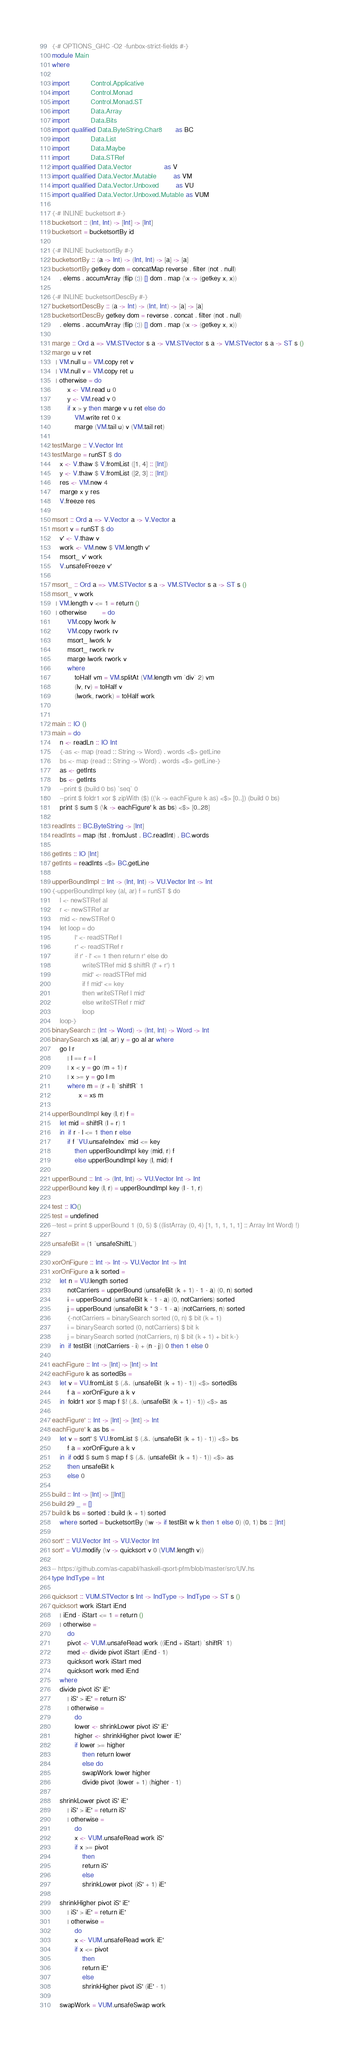<code> <loc_0><loc_0><loc_500><loc_500><_Haskell_>{-# OPTIONS_GHC -O2 -funbox-strict-fields #-}
module Main
where

import           Control.Applicative
import           Control.Monad
import           Control.Monad.ST
import           Data.Array
import           Data.Bits
import qualified Data.ByteString.Char8       as BC
import           Data.List
import           Data.Maybe
import           Data.STRef
import qualified Data.Vector                 as V
import qualified Data.Vector.Mutable         as VM
import qualified Data.Vector.Unboxed         as VU
import qualified Data.Vector.Unboxed.Mutable as VUM

{-# INLINE bucketsort #-}
bucketsort :: (Int, Int) -> [Int] -> [Int]
bucketsort = bucketsortBy id

{-# INLINE bucketsortBy #-}
bucketsortBy :: (a -> Int) -> (Int, Int) -> [a] -> [a]
bucketsortBy getkey dom = concatMap reverse . filter (not . null)
    . elems . accumArray (flip (:)) [] dom . map (\x -> (getkey x, x))

{-# INLINE bucketsortDescBy #-}
bucketsortDescBy :: (a -> Int) -> (Int, Int) -> [a] -> [a]
bucketsortDescBy getkey dom = reverse . concat . filter (not . null)
    . elems . accumArray (flip (:)) [] dom . map (\x -> (getkey x, x))

marge :: Ord a => VM.STVector s a -> VM.STVector s a -> VM.STVector s a -> ST s ()
marge u v ret
  | VM.null u = VM.copy ret v
  | VM.null v = VM.copy ret u
  | otherwise = do
        x <- VM.read u 0
        y <- VM.read v 0
        if x > y then marge v u ret else do
            VM.write ret 0 x
            marge (VM.tail u) v (VM.tail ret)

testMarge :: V.Vector Int
testMarge = runST $ do
    x <- V.thaw $ V.fromList ([1, 4] :: [Int])
    y <- V.thaw $ V.fromList ([2, 3] :: [Int])
    res <- VM.new 4
    marge x y res
    V.freeze res

msort :: Ord a => V.Vector a -> V.Vector a
msort v = runST $ do
    v' <- V.thaw v
    work <- VM.new $ VM.length v'
    msort_ v' work
    V.unsafeFreeze v'

msort_ :: Ord a => VM.STVector s a -> VM.STVector s a -> ST s ()
msort_ v work
  | VM.length v <= 1 = return ()
  | otherwise        = do
        VM.copy lwork lv
        VM.copy rwork rv
        msort_ lwork lv
        msort_ rwork rv
        marge lwork rwork v
        where
            toHalf vm = VM.splitAt (VM.length vm `div` 2) vm
            (lv, rv) = toHalf v
            (lwork, rwork) = toHalf work


main :: IO ()
main = do
    n <- readLn :: IO Int
    {-as <- map (read :: String -> Word) . words <$> getLine
    bs <- map (read :: String -> Word) . words <$> getLine-}
    as <- getInts
    bs <- getInts
    --print $ (build 0 bs) `seq` 0
    --print $ foldr1 xor $ zipWith ($) ((\k -> eachFigure k as) <$> [0..]) (build 0 bs)
    print $ sum $ (\k -> eachFigure' k as bs) <$> [0..28]

readInts :: BC.ByteString -> [Int]
readInts = map (fst . fromJust . BC.readInt) . BC.words

getInts :: IO [Int]
getInts = readInts <$> BC.getLine

upperBoundImpl :: Int -> (Int, Int) -> VU.Vector Int -> Int
{-upperBoundImpl key (al, ar) f = runST $ do
    l <- newSTRef al
    r <- newSTRef ar
    mid <- newSTRef 0
    let loop = do
            l' <- readSTRef l
            r' <- readSTRef r
            if r' - l' <= 1 then return r' else do
                writeSTRef mid $ shiftR (l' + r') 1
                mid' <- readSTRef mid
                if f mid' <= key
                then writeSTRef l mid'
                else writeSTRef r mid'
                loop
    loop-}
binarySearch :: (Int -> Word) -> (Int, Int) -> Word -> Int
binarySearch xs (al, ar) y = go al ar where
    go l r
        | l == r = l
        | x < y = go (m + 1) r
        | x >= y = go l m
        where m = (r + l) `shiftR` 1
              x = xs m

upperBoundImpl key (l, r) f =
    let mid = shiftR (l + r) 1
    in  if r - l <= 1 then r else
        if f `VU.unsafeIndex` mid <= key
            then upperBoundImpl key (mid, r) f
            else upperBoundImpl key (l, mid) f

upperBound :: Int -> (Int, Int) -> VU.Vector Int -> Int
upperBound key (l, r) = upperBoundImpl key (l - 1, r)

test :: IO()
test = undefined
--test = print $ upperBound 1 (0, 5) $ ((listArray (0, 4) [1, 1, 1, 1, 1] :: Array Int Word) !)

unsafeBit = (1 `unsafeShiftL`)

xorOnFigure :: Int -> Int -> VU.Vector Int -> Int
xorOnFigure a k sorted =
    let n = VU.length sorted
        notCarriers = upperBound (unsafeBit (k + 1) - 1 - a) (0, n) sorted
        i = upperBound (unsafeBit k - 1 - a) (0, notCarriers) sorted
        j = upperBound (unsafeBit k * 3 - 1 - a) (notCarriers, n) sorted
        {-notCarriers = binarySearch sorted (0, n) $ bit (k + 1)
        i = binarySearch sorted (0, notCarriers) $ bit k
        j = binarySearch sorted (notCarriers, n) $ bit (k + 1) + bit k-}
    in  if testBit ((notCarriers - i) + (n - j)) 0 then 1 else 0

eachFigure :: Int -> [Int] -> [Int] -> Int
eachFigure k as sortedBs =
    let v = VU.fromList $ (.&. (unsafeBit (k + 1) - 1)) <$> sortedBs
        f a = xorOnFigure a k v
    in  foldr1 xor $ map f $! (.&. (unsafeBit (k + 1) - 1)) <$> as

eachFigure' :: Int -> [Int] -> [Int] -> Int
eachFigure' k as bs =
    let v = sort' $ VU.fromList $ (.&. (unsafeBit (k + 1) - 1)) <$> bs
        f a = xorOnFigure a k v
    in  if odd $ sum $ map f $ (.&. (unsafeBit (k + 1) - 1)) <$> as
        then unsafeBit k
        else 0

build :: Int -> [Int] -> [[Int]]
build 29 _ = []
build k bs = sorted : build (k + 1) sorted
    where sorted = bucketsortBy (\w -> if testBit w k then 1 else 0) (0, 1) bs :: [Int]

sort' :: VU.Vector Int -> VU.Vector Int
sort' = VU.modify (\v -> quicksort v 0 (VUM.length v))

-- https://github.com/as-capabl/haskell-qsort-pfm/blob/master/src/UV.hs
type IndType = Int

quicksort :: VUM.STVector s Int -> IndType -> IndType -> ST s ()
quicksort work iStart iEnd
    | iEnd - iStart <= 1 = return ()
    | otherwise =
        do
        pivot <- VUM.unsafeRead work ((iEnd + iStart) `shiftR` 1)
        med <- divide pivot iStart (iEnd - 1)
        quicksort work iStart med
        quicksort work med iEnd
    where
    divide pivot iS' iE'
        | iS' > iE' = return iS'
        | otherwise =
            do
            lower <- shrinkLower pivot iS' iE'
            higher <- shrinkHigher pivot lower iE'
            if lower >= higher
                then return lower
                else do
                swapWork lower higher
                divide pivot (lower + 1) (higher - 1)

    shrinkLower pivot iS' iE'
        | iS' > iE' = return iS'
        | otherwise =
            do
            x <- VUM.unsafeRead work iS'
            if x >= pivot
                then
                return iS'
                else
                shrinkLower pivot (iS' + 1) iE'

    shrinkHigher pivot iS' iE'
        | iS' > iE' = return iE'
        | otherwise =
            do
            x <- VUM.unsafeRead work iE'
            if x <= pivot
                then
                return iE'
                else
                shrinkHigher pivot iS' (iE' - 1)

    swapWork = VUM.unsafeSwap work
</code> 